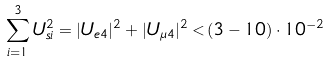Convert formula to latex. <formula><loc_0><loc_0><loc_500><loc_500>\sum _ { i = 1 } ^ { 3 } U _ { s i } ^ { 2 } = | U _ { e 4 } | ^ { 2 } + | U _ { \mu 4 } | ^ { 2 } < ( 3 - 1 0 ) \cdot 1 0 ^ { - 2 }</formula> 